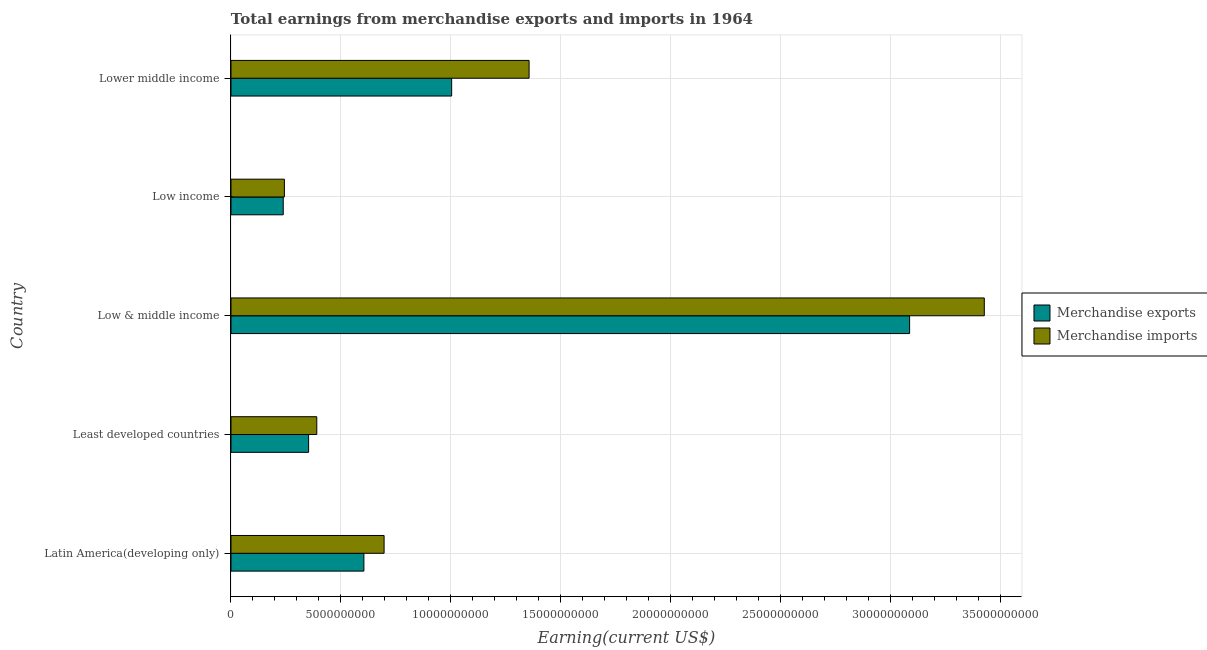How many groups of bars are there?
Offer a very short reply. 5. What is the label of the 1st group of bars from the top?
Provide a succinct answer. Lower middle income. In how many cases, is the number of bars for a given country not equal to the number of legend labels?
Keep it short and to the point. 0. What is the earnings from merchandise imports in Least developed countries?
Keep it short and to the point. 3.91e+09. Across all countries, what is the maximum earnings from merchandise imports?
Offer a very short reply. 3.43e+1. Across all countries, what is the minimum earnings from merchandise exports?
Keep it short and to the point. 2.38e+09. In which country was the earnings from merchandise imports minimum?
Give a very brief answer. Low income. What is the total earnings from merchandise imports in the graph?
Your answer should be very brief. 6.12e+1. What is the difference between the earnings from merchandise imports in Least developed countries and that in Low income?
Offer a terse response. 1.47e+09. What is the difference between the earnings from merchandise exports in Low & middle income and the earnings from merchandise imports in Low income?
Offer a terse response. 2.85e+1. What is the average earnings from merchandise imports per country?
Provide a short and direct response. 1.22e+1. What is the difference between the earnings from merchandise exports and earnings from merchandise imports in Low & middle income?
Give a very brief answer. -3.40e+09. What is the ratio of the earnings from merchandise exports in Least developed countries to that in Low & middle income?
Offer a terse response. 0.11. Is the earnings from merchandise exports in Latin America(developing only) less than that in Low income?
Your response must be concise. No. What is the difference between the highest and the second highest earnings from merchandise imports?
Your answer should be compact. 2.07e+1. What is the difference between the highest and the lowest earnings from merchandise imports?
Offer a terse response. 3.19e+1. Is the sum of the earnings from merchandise imports in Least developed countries and Low income greater than the maximum earnings from merchandise exports across all countries?
Your answer should be very brief. No. What does the 2nd bar from the top in Least developed countries represents?
Give a very brief answer. Merchandise exports. Are all the bars in the graph horizontal?
Give a very brief answer. Yes. What is the difference between two consecutive major ticks on the X-axis?
Provide a short and direct response. 5.00e+09. Does the graph contain grids?
Your answer should be compact. Yes. Where does the legend appear in the graph?
Provide a succinct answer. Center right. What is the title of the graph?
Provide a short and direct response. Total earnings from merchandise exports and imports in 1964. What is the label or title of the X-axis?
Provide a succinct answer. Earning(current US$). What is the label or title of the Y-axis?
Give a very brief answer. Country. What is the Earning(current US$) of Merchandise exports in Latin America(developing only)?
Your answer should be compact. 6.05e+09. What is the Earning(current US$) in Merchandise imports in Latin America(developing only)?
Keep it short and to the point. 6.97e+09. What is the Earning(current US$) in Merchandise exports in Least developed countries?
Offer a very short reply. 3.53e+09. What is the Earning(current US$) in Merchandise imports in Least developed countries?
Your answer should be very brief. 3.91e+09. What is the Earning(current US$) in Merchandise exports in Low & middle income?
Your answer should be very brief. 3.09e+1. What is the Earning(current US$) of Merchandise imports in Low & middle income?
Offer a terse response. 3.43e+1. What is the Earning(current US$) of Merchandise exports in Low income?
Offer a terse response. 2.38e+09. What is the Earning(current US$) in Merchandise imports in Low income?
Offer a very short reply. 2.43e+09. What is the Earning(current US$) of Merchandise exports in Lower middle income?
Ensure brevity in your answer.  1.00e+1. What is the Earning(current US$) in Merchandise imports in Lower middle income?
Make the answer very short. 1.36e+1. Across all countries, what is the maximum Earning(current US$) of Merchandise exports?
Provide a succinct answer. 3.09e+1. Across all countries, what is the maximum Earning(current US$) in Merchandise imports?
Your answer should be very brief. 3.43e+1. Across all countries, what is the minimum Earning(current US$) in Merchandise exports?
Your answer should be compact. 2.38e+09. Across all countries, what is the minimum Earning(current US$) in Merchandise imports?
Provide a succinct answer. 2.43e+09. What is the total Earning(current US$) of Merchandise exports in the graph?
Offer a very short reply. 5.29e+1. What is the total Earning(current US$) of Merchandise imports in the graph?
Ensure brevity in your answer.  6.12e+1. What is the difference between the Earning(current US$) in Merchandise exports in Latin America(developing only) and that in Least developed countries?
Your answer should be compact. 2.52e+09. What is the difference between the Earning(current US$) in Merchandise imports in Latin America(developing only) and that in Least developed countries?
Ensure brevity in your answer.  3.06e+09. What is the difference between the Earning(current US$) of Merchandise exports in Latin America(developing only) and that in Low & middle income?
Make the answer very short. -2.48e+1. What is the difference between the Earning(current US$) in Merchandise imports in Latin America(developing only) and that in Low & middle income?
Your response must be concise. -2.73e+1. What is the difference between the Earning(current US$) in Merchandise exports in Latin America(developing only) and that in Low income?
Your response must be concise. 3.67e+09. What is the difference between the Earning(current US$) of Merchandise imports in Latin America(developing only) and that in Low income?
Keep it short and to the point. 4.54e+09. What is the difference between the Earning(current US$) in Merchandise exports in Latin America(developing only) and that in Lower middle income?
Offer a very short reply. -3.99e+09. What is the difference between the Earning(current US$) of Merchandise imports in Latin America(developing only) and that in Lower middle income?
Your answer should be compact. -6.60e+09. What is the difference between the Earning(current US$) of Merchandise exports in Least developed countries and that in Low & middle income?
Your response must be concise. -2.74e+1. What is the difference between the Earning(current US$) in Merchandise imports in Least developed countries and that in Low & middle income?
Make the answer very short. -3.04e+1. What is the difference between the Earning(current US$) of Merchandise exports in Least developed countries and that in Low income?
Ensure brevity in your answer.  1.15e+09. What is the difference between the Earning(current US$) of Merchandise imports in Least developed countries and that in Low income?
Provide a short and direct response. 1.47e+09. What is the difference between the Earning(current US$) in Merchandise exports in Least developed countries and that in Lower middle income?
Offer a very short reply. -6.51e+09. What is the difference between the Earning(current US$) in Merchandise imports in Least developed countries and that in Lower middle income?
Offer a very short reply. -9.66e+09. What is the difference between the Earning(current US$) of Merchandise exports in Low & middle income and that in Low income?
Provide a short and direct response. 2.85e+1. What is the difference between the Earning(current US$) of Merchandise imports in Low & middle income and that in Low income?
Offer a terse response. 3.19e+1. What is the difference between the Earning(current US$) in Merchandise exports in Low & middle income and that in Lower middle income?
Your answer should be compact. 2.08e+1. What is the difference between the Earning(current US$) of Merchandise imports in Low & middle income and that in Lower middle income?
Your answer should be very brief. 2.07e+1. What is the difference between the Earning(current US$) of Merchandise exports in Low income and that in Lower middle income?
Provide a succinct answer. -7.66e+09. What is the difference between the Earning(current US$) in Merchandise imports in Low income and that in Lower middle income?
Give a very brief answer. -1.11e+1. What is the difference between the Earning(current US$) in Merchandise exports in Latin America(developing only) and the Earning(current US$) in Merchandise imports in Least developed countries?
Provide a succinct answer. 2.14e+09. What is the difference between the Earning(current US$) in Merchandise exports in Latin America(developing only) and the Earning(current US$) in Merchandise imports in Low & middle income?
Your answer should be compact. -2.82e+1. What is the difference between the Earning(current US$) of Merchandise exports in Latin America(developing only) and the Earning(current US$) of Merchandise imports in Low income?
Offer a very short reply. 3.62e+09. What is the difference between the Earning(current US$) of Merchandise exports in Latin America(developing only) and the Earning(current US$) of Merchandise imports in Lower middle income?
Offer a very short reply. -7.52e+09. What is the difference between the Earning(current US$) in Merchandise exports in Least developed countries and the Earning(current US$) in Merchandise imports in Low & middle income?
Your response must be concise. -3.08e+1. What is the difference between the Earning(current US$) of Merchandise exports in Least developed countries and the Earning(current US$) of Merchandise imports in Low income?
Ensure brevity in your answer.  1.10e+09. What is the difference between the Earning(current US$) in Merchandise exports in Least developed countries and the Earning(current US$) in Merchandise imports in Lower middle income?
Give a very brief answer. -1.00e+1. What is the difference between the Earning(current US$) in Merchandise exports in Low & middle income and the Earning(current US$) in Merchandise imports in Low income?
Provide a succinct answer. 2.85e+1. What is the difference between the Earning(current US$) of Merchandise exports in Low & middle income and the Earning(current US$) of Merchandise imports in Lower middle income?
Give a very brief answer. 1.73e+1. What is the difference between the Earning(current US$) in Merchandise exports in Low income and the Earning(current US$) in Merchandise imports in Lower middle income?
Offer a terse response. -1.12e+1. What is the average Earning(current US$) in Merchandise exports per country?
Give a very brief answer. 1.06e+1. What is the average Earning(current US$) of Merchandise imports per country?
Keep it short and to the point. 1.22e+1. What is the difference between the Earning(current US$) of Merchandise exports and Earning(current US$) of Merchandise imports in Latin America(developing only)?
Provide a short and direct response. -9.19e+08. What is the difference between the Earning(current US$) in Merchandise exports and Earning(current US$) in Merchandise imports in Least developed countries?
Provide a succinct answer. -3.72e+08. What is the difference between the Earning(current US$) of Merchandise exports and Earning(current US$) of Merchandise imports in Low & middle income?
Offer a terse response. -3.40e+09. What is the difference between the Earning(current US$) in Merchandise exports and Earning(current US$) in Merchandise imports in Low income?
Provide a short and direct response. -5.31e+07. What is the difference between the Earning(current US$) in Merchandise exports and Earning(current US$) in Merchandise imports in Lower middle income?
Ensure brevity in your answer.  -3.52e+09. What is the ratio of the Earning(current US$) of Merchandise exports in Latin America(developing only) to that in Least developed countries?
Your response must be concise. 1.71. What is the ratio of the Earning(current US$) of Merchandise imports in Latin America(developing only) to that in Least developed countries?
Your response must be concise. 1.78. What is the ratio of the Earning(current US$) in Merchandise exports in Latin America(developing only) to that in Low & middle income?
Offer a terse response. 0.2. What is the ratio of the Earning(current US$) in Merchandise imports in Latin America(developing only) to that in Low & middle income?
Provide a succinct answer. 0.2. What is the ratio of the Earning(current US$) of Merchandise exports in Latin America(developing only) to that in Low income?
Ensure brevity in your answer.  2.54. What is the ratio of the Earning(current US$) in Merchandise imports in Latin America(developing only) to that in Low income?
Ensure brevity in your answer.  2.87. What is the ratio of the Earning(current US$) in Merchandise exports in Latin America(developing only) to that in Lower middle income?
Keep it short and to the point. 0.6. What is the ratio of the Earning(current US$) of Merchandise imports in Latin America(developing only) to that in Lower middle income?
Ensure brevity in your answer.  0.51. What is the ratio of the Earning(current US$) of Merchandise exports in Least developed countries to that in Low & middle income?
Give a very brief answer. 0.11. What is the ratio of the Earning(current US$) in Merchandise imports in Least developed countries to that in Low & middle income?
Provide a succinct answer. 0.11. What is the ratio of the Earning(current US$) of Merchandise exports in Least developed countries to that in Low income?
Provide a short and direct response. 1.49. What is the ratio of the Earning(current US$) of Merchandise imports in Least developed countries to that in Low income?
Offer a very short reply. 1.61. What is the ratio of the Earning(current US$) in Merchandise exports in Least developed countries to that in Lower middle income?
Provide a succinct answer. 0.35. What is the ratio of the Earning(current US$) of Merchandise imports in Least developed countries to that in Lower middle income?
Offer a very short reply. 0.29. What is the ratio of the Earning(current US$) in Merchandise exports in Low & middle income to that in Low income?
Keep it short and to the point. 12.99. What is the ratio of the Earning(current US$) in Merchandise imports in Low & middle income to that in Low income?
Offer a very short reply. 14.1. What is the ratio of the Earning(current US$) of Merchandise exports in Low & middle income to that in Lower middle income?
Your answer should be very brief. 3.08. What is the ratio of the Earning(current US$) of Merchandise imports in Low & middle income to that in Lower middle income?
Make the answer very short. 2.53. What is the ratio of the Earning(current US$) in Merchandise exports in Low income to that in Lower middle income?
Your response must be concise. 0.24. What is the ratio of the Earning(current US$) of Merchandise imports in Low income to that in Lower middle income?
Offer a very short reply. 0.18. What is the difference between the highest and the second highest Earning(current US$) in Merchandise exports?
Make the answer very short. 2.08e+1. What is the difference between the highest and the second highest Earning(current US$) of Merchandise imports?
Provide a succinct answer. 2.07e+1. What is the difference between the highest and the lowest Earning(current US$) in Merchandise exports?
Ensure brevity in your answer.  2.85e+1. What is the difference between the highest and the lowest Earning(current US$) in Merchandise imports?
Give a very brief answer. 3.19e+1. 